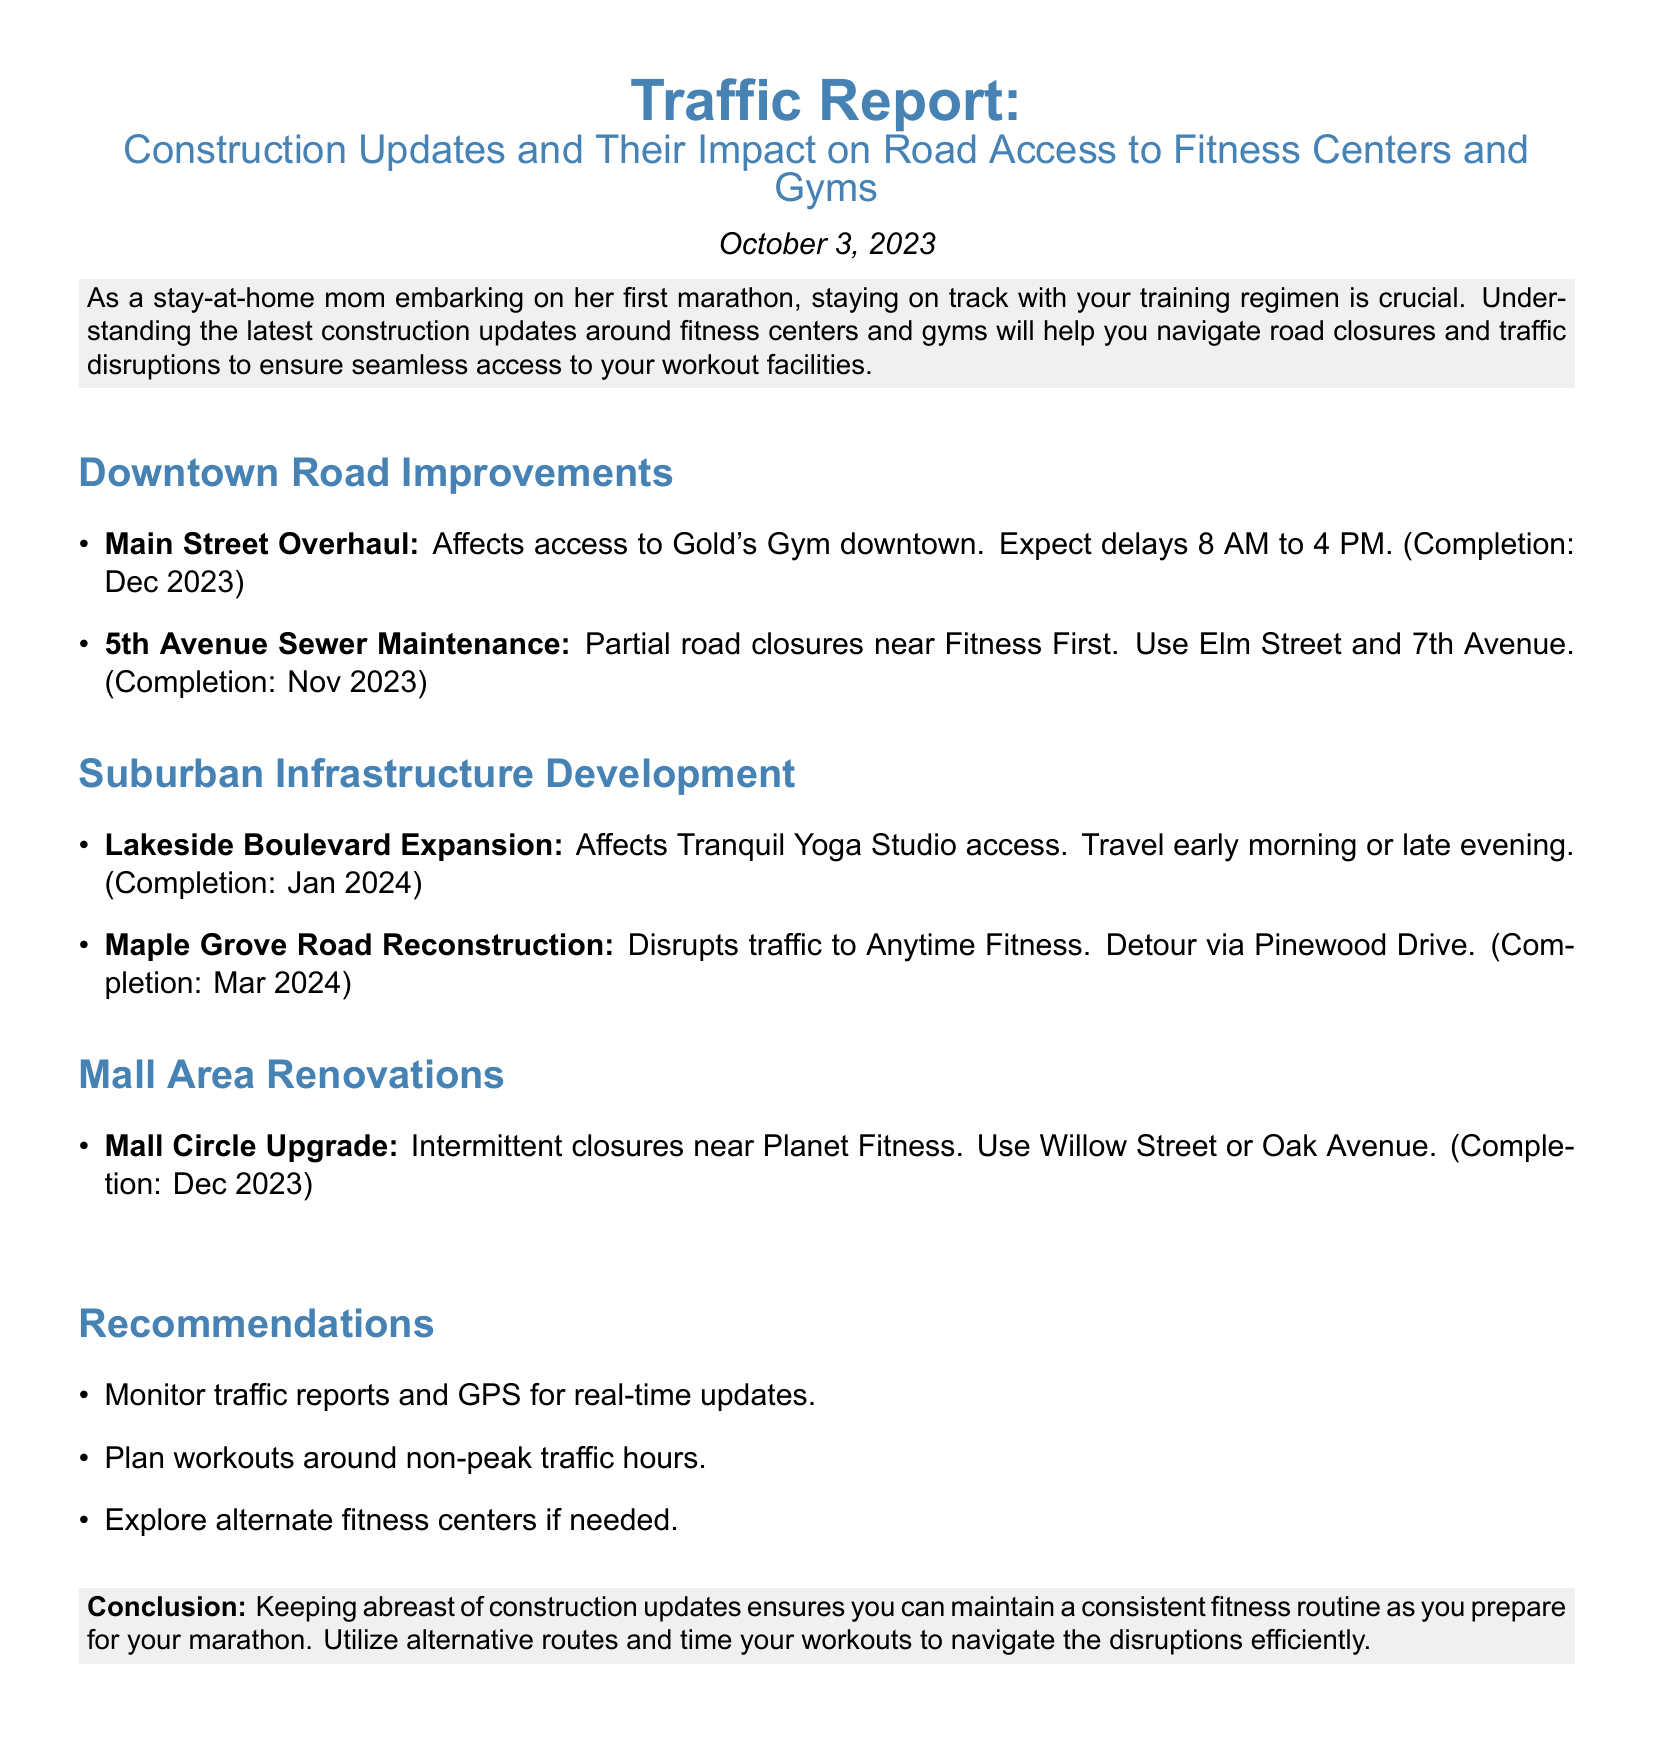What construction affects access to Gold's Gym? The report specifies that the Main Street Overhaul affects access to Gold's Gym downtown.
Answer: Main Street Overhaul What is the completion date for 5th Avenue Sewer Maintenance? The document states the completion date for the 5th Avenue Sewer Maintenance as November 2023.
Answer: Nov 2023 Which fitness center is affected by Lakeside Boulevard Expansion? The report indicates that the Lakeside Boulevard Expansion affects access to Tranquil Yoga Studio.
Answer: Tranquil Yoga Studio What alternate route is suggested for traffic disruptions to Anytime Fitness? The document suggests using Pinewood Drive as an alternate route for traffic disruptions to Anytime Fitness.
Answer: Pinewood Drive When is the expected completion date for the Maple Grove Road Reconstruction? The report indicates that the completion date for the Maple Grove Road Reconstruction is March 2024.
Answer: Mar 2024 What are two recommendations for avoiding traffic disruptions? The report recommends monitoring traffic reports and planning workouts around non-peak traffic hours to avoid disruptions.
Answer: Monitor traffic reports, Plan workouts around non-peak traffic hours How does the report indicate the impact of construction on accessing fitness centers? The document outlines the construction updates and their specific impacts on road access to various fitness centers.
Answer: Specific impacts on road access What is the color scheme used in the report? The report primarily uses shades of blue and light gray for its color scheme.
Answer: Blue and light gray 